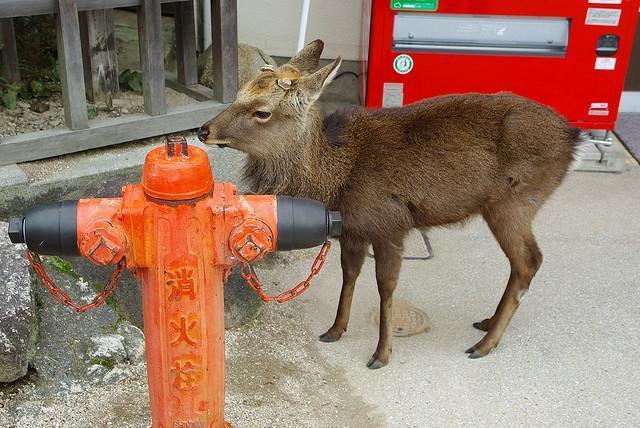How many fire hydrants are in the photo?
Give a very brief answer. 1. 